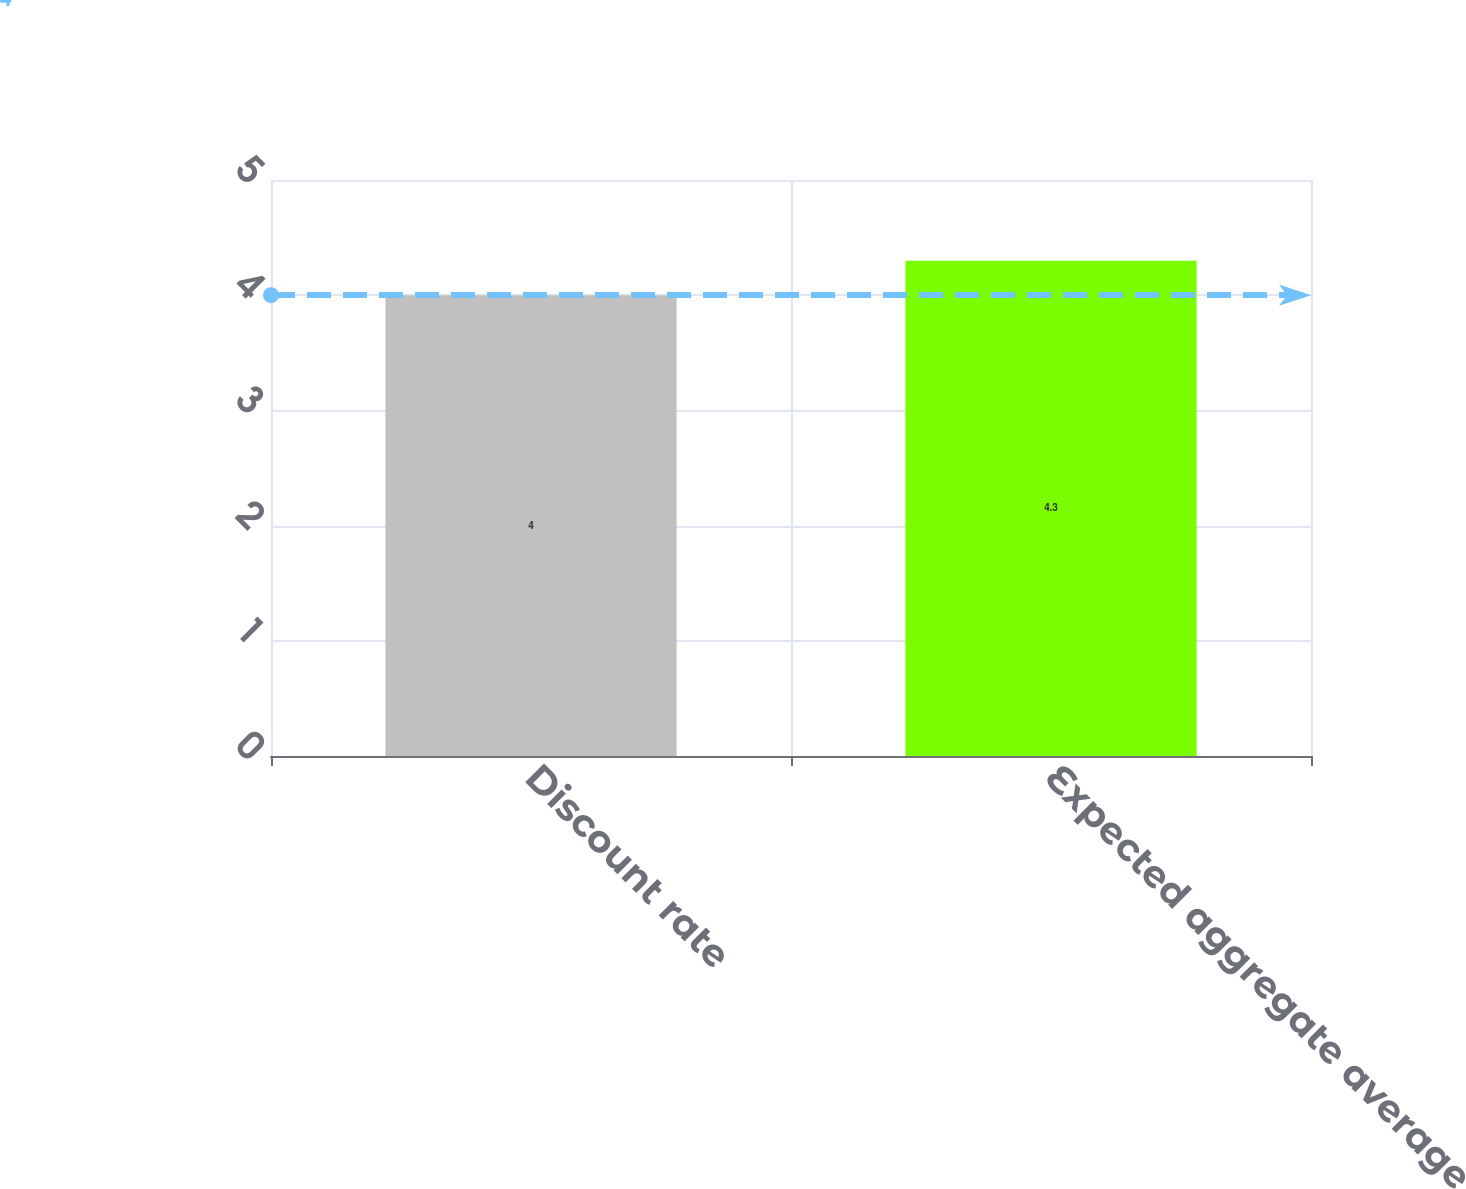<chart> <loc_0><loc_0><loc_500><loc_500><bar_chart><fcel>Discount rate<fcel>Expected aggregate average<nl><fcel>4<fcel>4.3<nl></chart> 